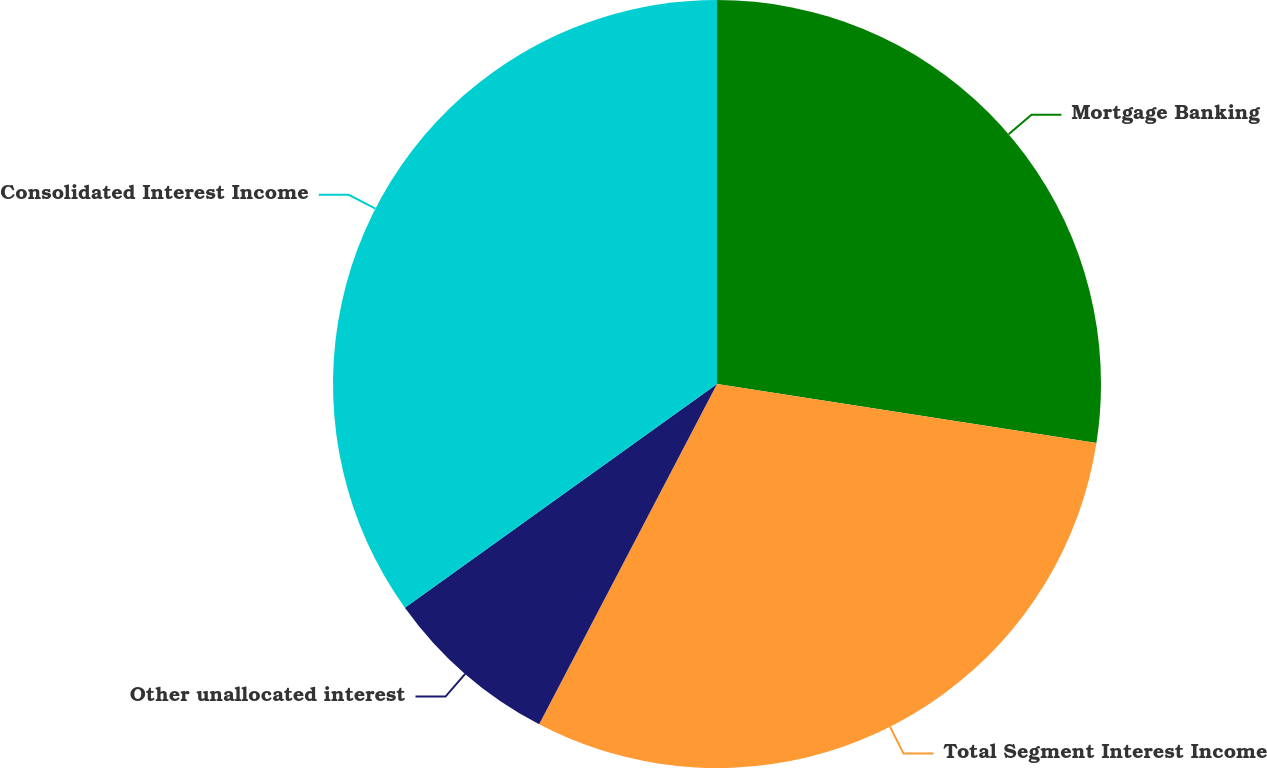Convert chart. <chart><loc_0><loc_0><loc_500><loc_500><pie_chart><fcel>Mortgage Banking<fcel>Total Segment Interest Income<fcel>Other unallocated interest<fcel>Consolidated Interest Income<nl><fcel>27.46%<fcel>30.21%<fcel>7.44%<fcel>34.9%<nl></chart> 